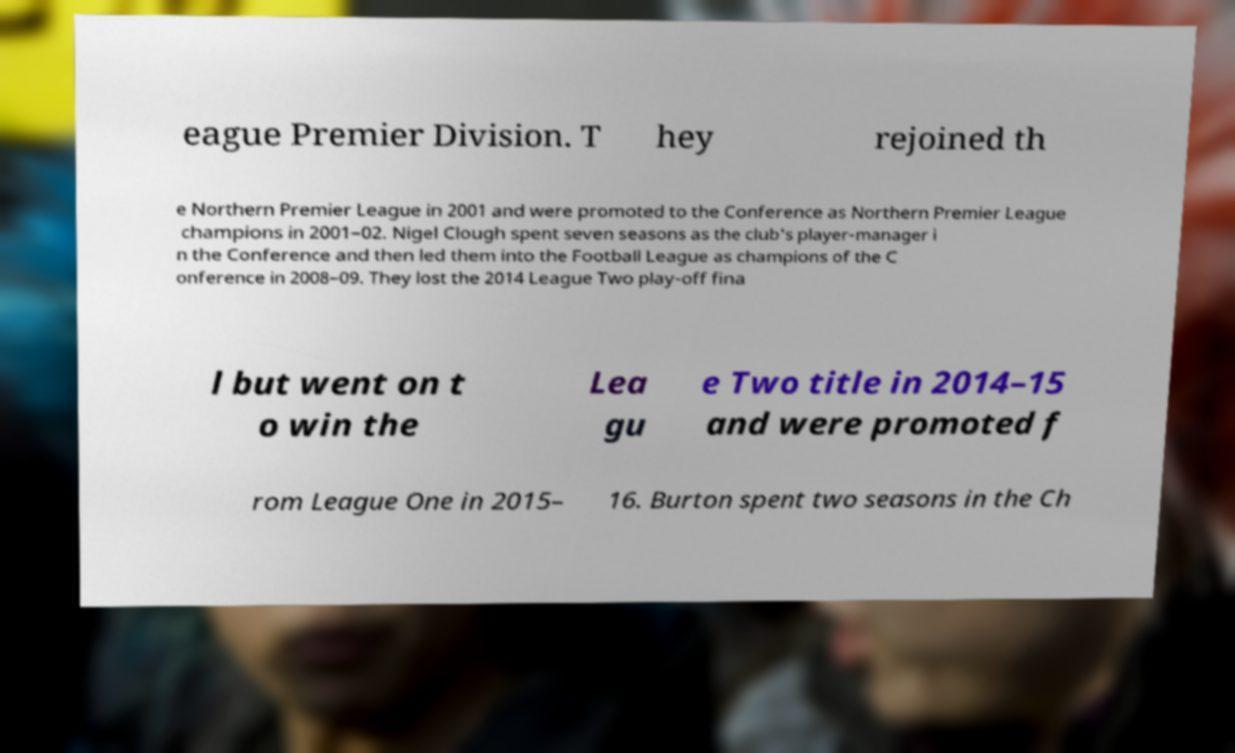Please identify and transcribe the text found in this image. eague Premier Division. T hey rejoined th e Northern Premier League in 2001 and were promoted to the Conference as Northern Premier League champions in 2001–02. Nigel Clough spent seven seasons as the club's player-manager i n the Conference and then led them into the Football League as champions of the C onference in 2008–09. They lost the 2014 League Two play-off fina l but went on t o win the Lea gu e Two title in 2014–15 and were promoted f rom League One in 2015– 16. Burton spent two seasons in the Ch 